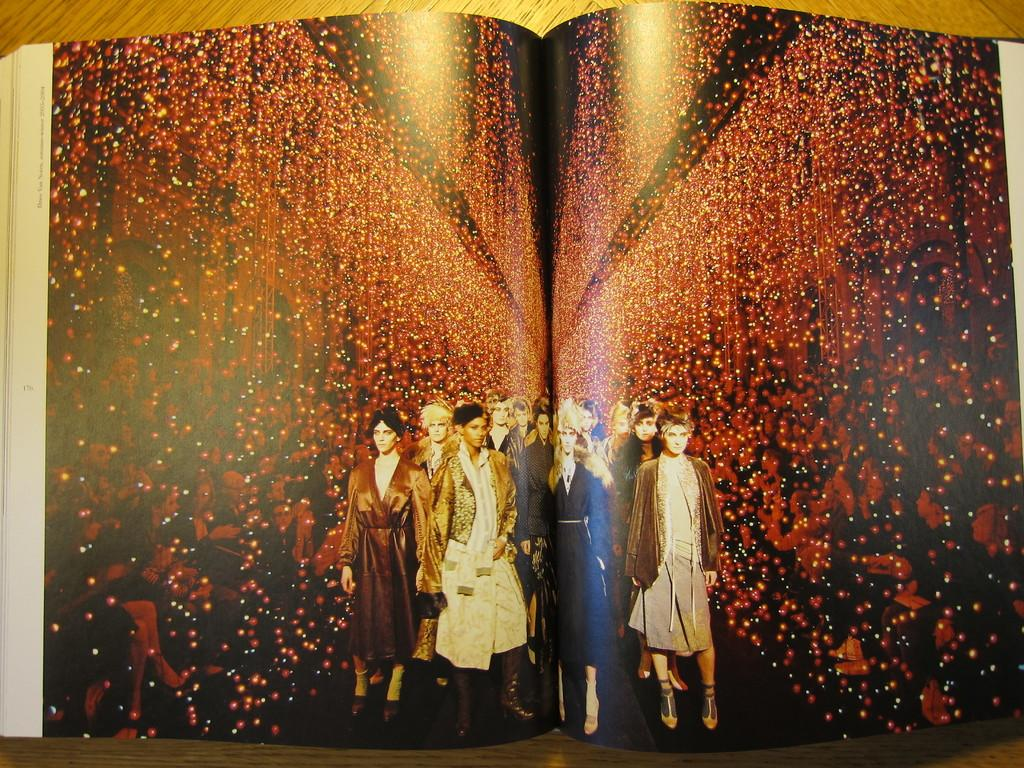What is the main subject of the book in the image? The book contains pictures of persons sitting on chairs. Are there any other images in the book besides the ones of persons sitting on chairs? Yes, the book contains a picture of a woman standing on a ramp. Can you see a bridge in the image? There is no bridge present in the image. What type of hose is being used by the woman in the image? There is no woman or hose present in the image; the book only contains pictures of persons sitting on chairs and a woman standing on a ramp. 